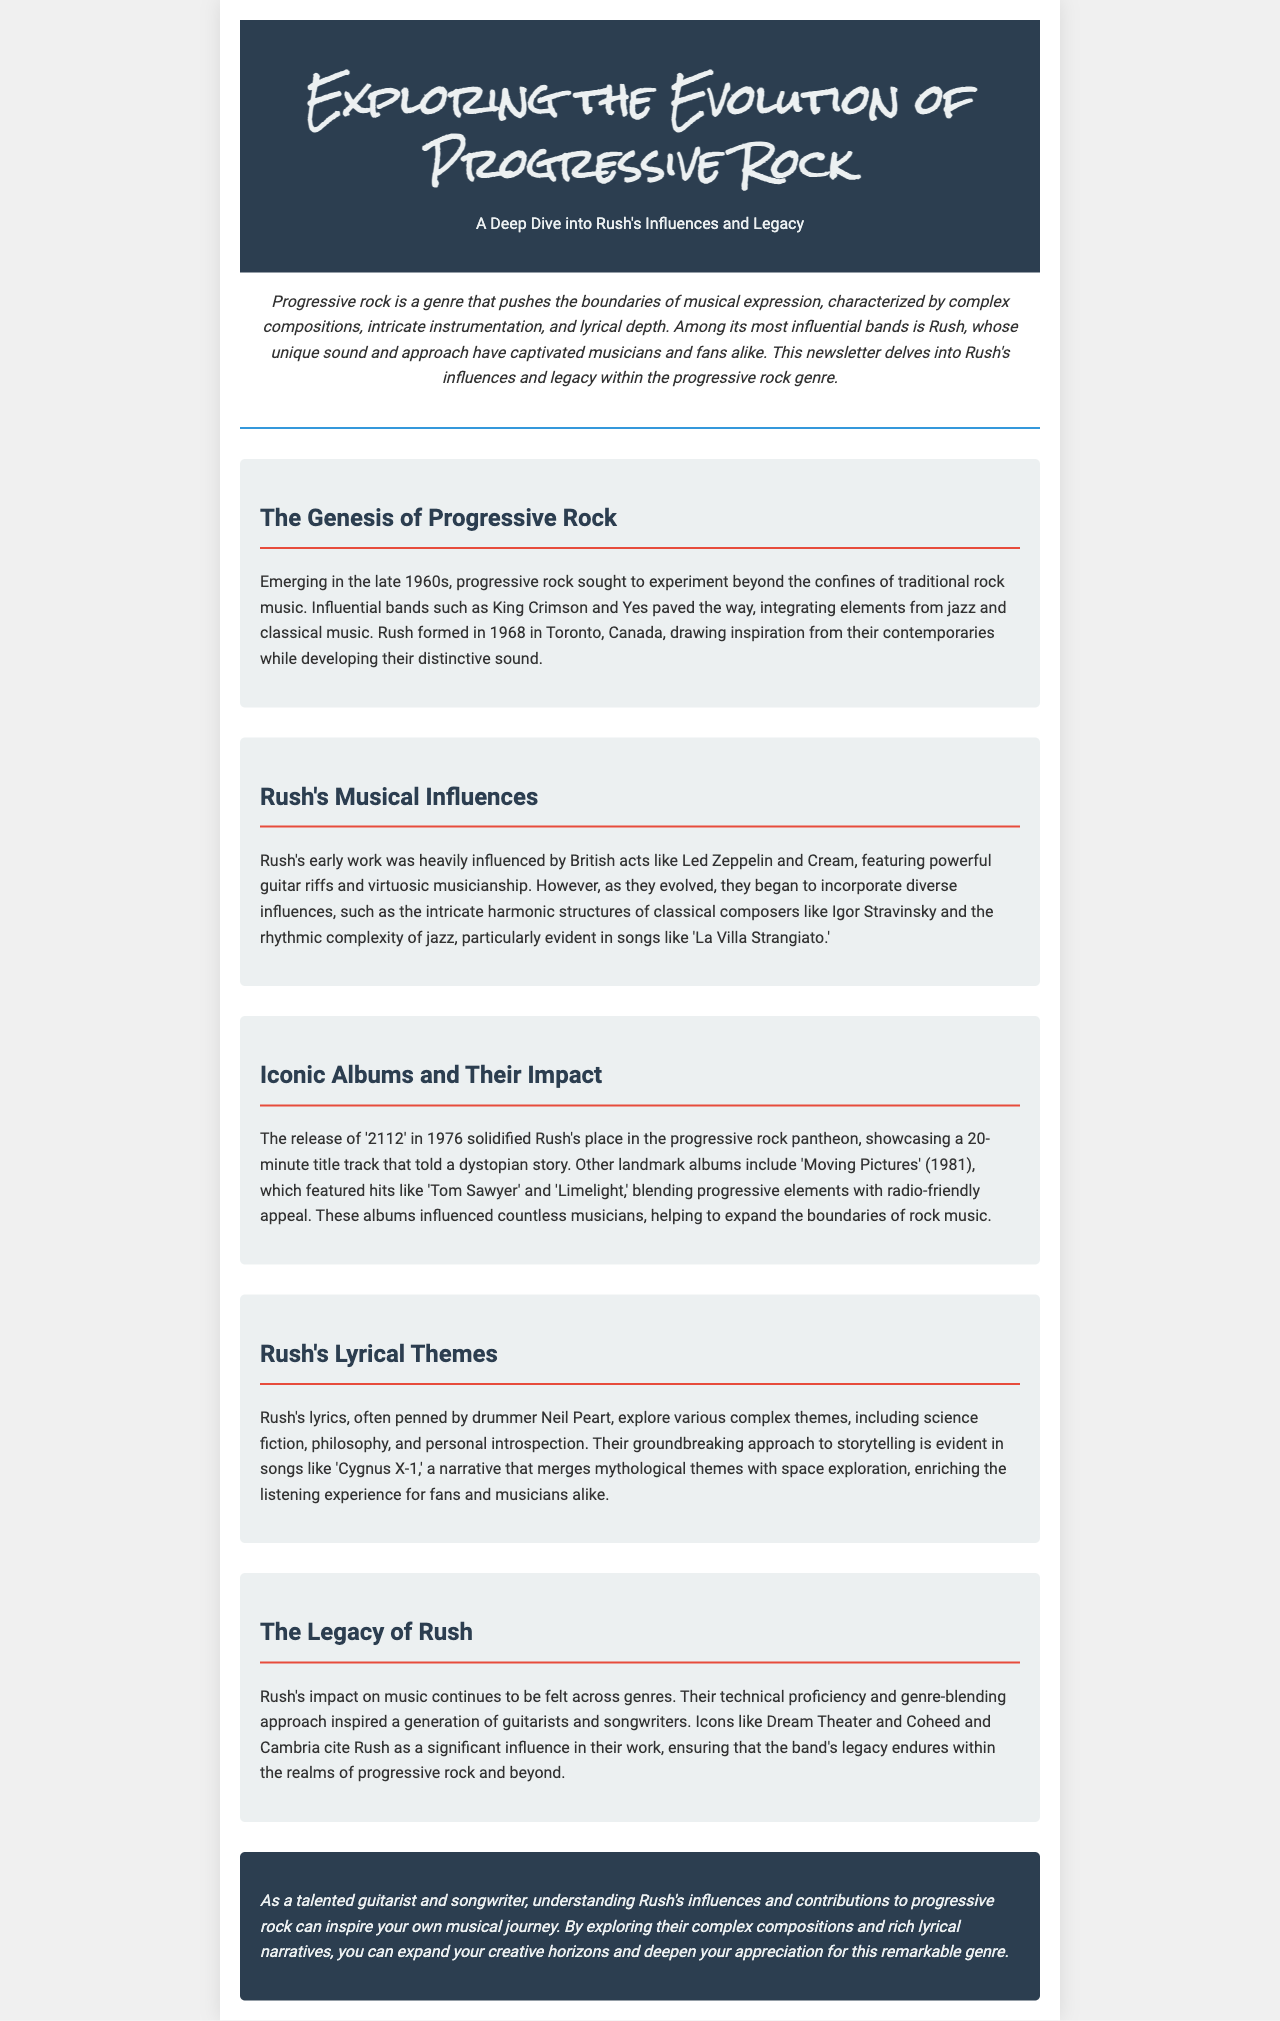What year was Rush formed? The document states that Rush was formed in 1968.
Answer: 1968 Which album featured the title track '2112'? The text mentions that the release of '2112' solidified Rush's place in the progressive rock pantheon.
Answer: 2112 What are some of the lyrical themes explored by Rush? The document lists science fiction, philosophy, and personal introspection as themes in Rush's lyrics.
Answer: Science fiction, philosophy, personal introspection Which bands were early influences on Rush's music? The section about Rush's musical influences mentions Led Zeppelin and Cream as early influences.
Answer: Led Zeppelin, Cream What significant impact did Rush have on later musicians? The document states that icons like Dream Theater and Coheed and Cambria cite Rush as a significant influence in their work.
Answer: Dream Theater, Coheed and Cambria How many minutes is the title track of '2112'? The newsletter mentions that '2112' showcases a 20-minute title track.
Answer: 20 minutes What year was the album 'Moving Pictures' released? The release year of 'Moving Pictures' is specified as 1981 in the document.
Answer: 1981 Which classical composer influenced Rush's music? The document references Igor Stravinsky as a classical influence on Rush's music.
Answer: Igor Stravinsky 